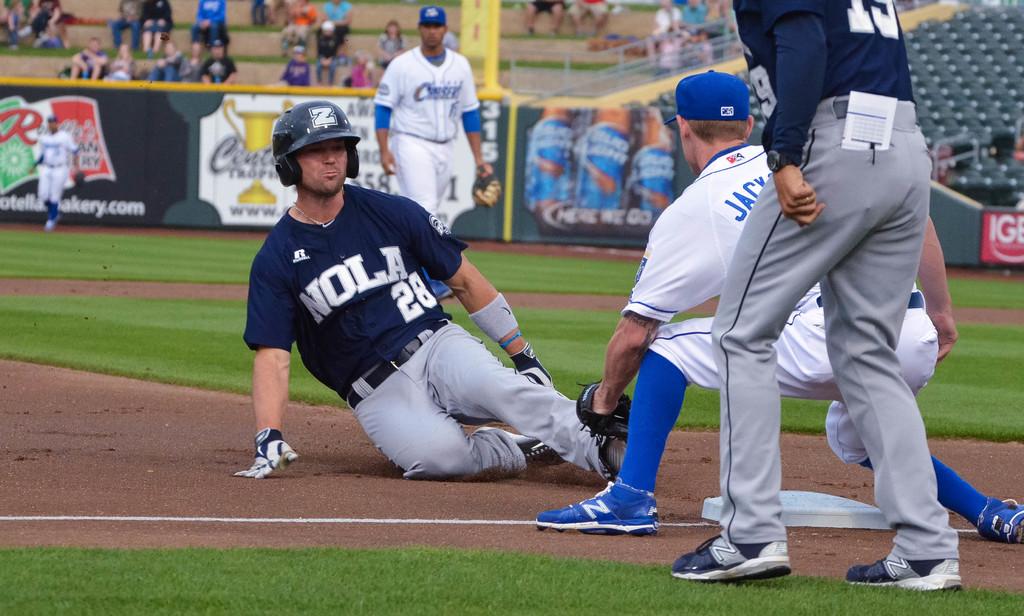What is the number of the man sliding into home?
Provide a short and direct response. 28. 